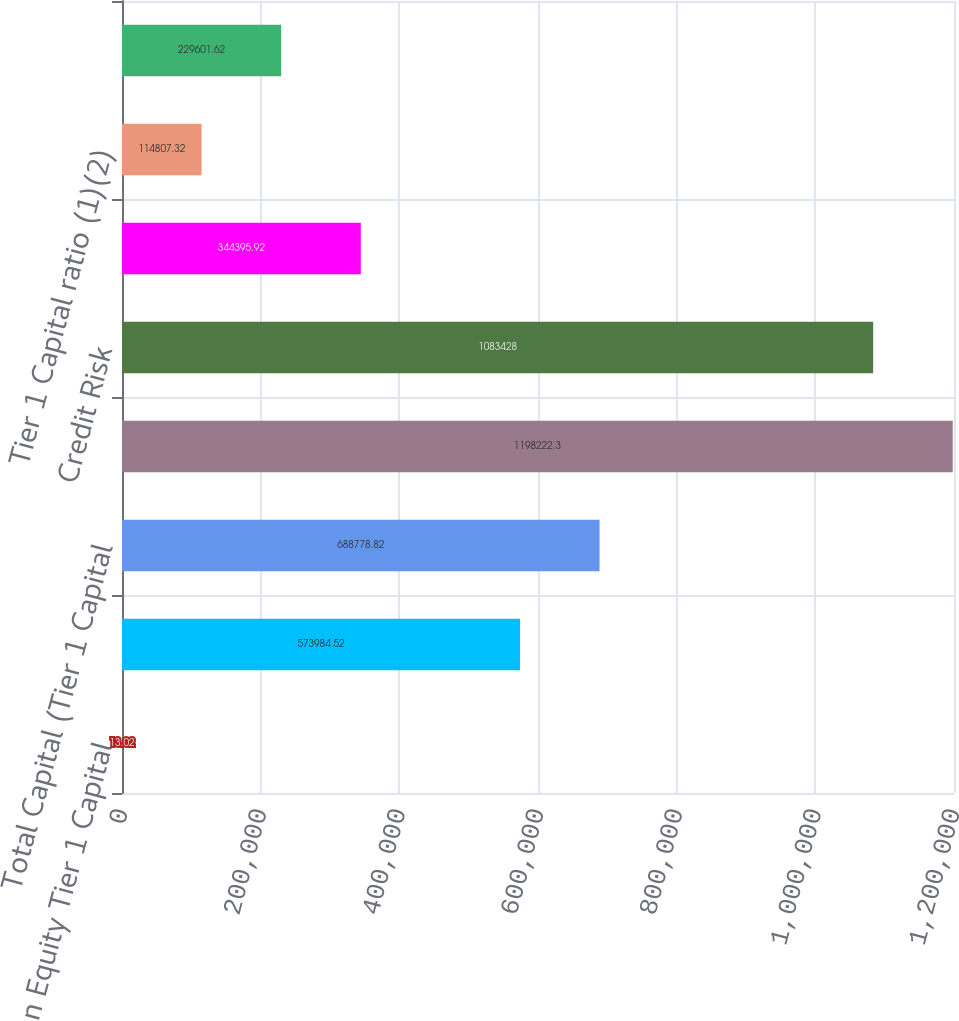<chart> <loc_0><loc_0><loc_500><loc_500><bar_chart><fcel>Common Equity Tier 1 Capital<fcel>Tier 1 Capital<fcel>Total Capital (Tier 1 Capital<fcel>Total Risk-Weighted Assets<fcel>Credit Risk<fcel>Market Risk<fcel>Tier 1 Capital ratio (1)(2)<fcel>Total Capital ratio (1)(2)<nl><fcel>13.02<fcel>573985<fcel>688779<fcel>1.19822e+06<fcel>1.08343e+06<fcel>344396<fcel>114807<fcel>229602<nl></chart> 